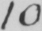Can you read and transcribe this handwriting? 10 . 